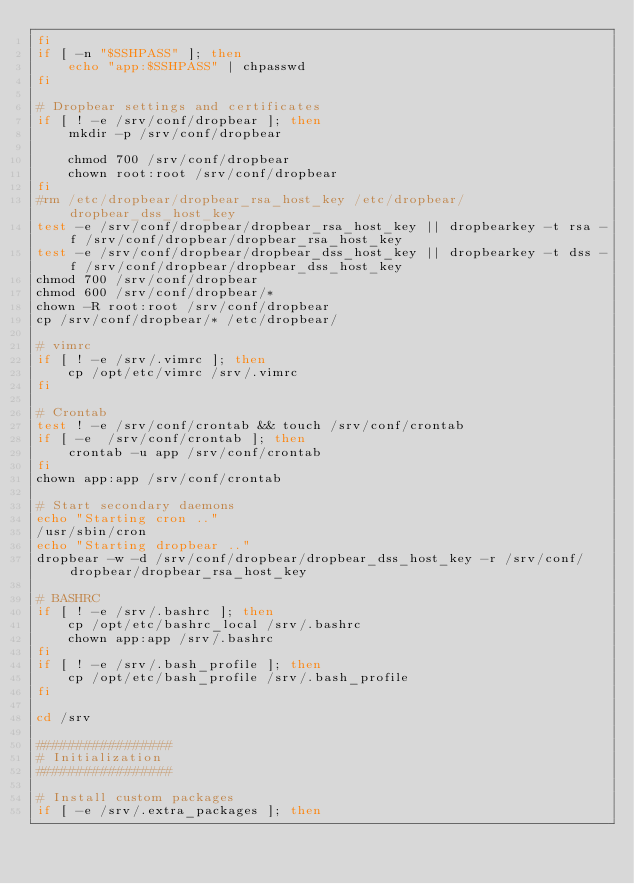Convert code to text. <code><loc_0><loc_0><loc_500><loc_500><_Bash_>fi
if [ -n "$SSHPASS" ]; then
    echo "app:$SSHPASS" | chpasswd
fi

# Dropbear settings and certificates
if [ ! -e /srv/conf/dropbear ]; then
    mkdir -p /srv/conf/dropbear

    chmod 700 /srv/conf/dropbear
    chown root:root /srv/conf/dropbear
fi
#rm /etc/dropbear/dropbear_rsa_host_key /etc/dropbear/dropbear_dss_host_key
test -e /srv/conf/dropbear/dropbear_rsa_host_key || dropbearkey -t rsa -f /srv/conf/dropbear/dropbear_rsa_host_key
test -e /srv/conf/dropbear/dropbear_dss_host_key || dropbearkey -t dss -f /srv/conf/dropbear/dropbear_dss_host_key
chmod 700 /srv/conf/dropbear
chmod 600 /srv/conf/dropbear/*
chown -R root:root /srv/conf/dropbear
cp /srv/conf/dropbear/* /etc/dropbear/

# vimrc
if [ ! -e /srv/.vimrc ]; then
    cp /opt/etc/vimrc /srv/.vimrc
fi

# Crontab
test ! -e /srv/conf/crontab && touch /srv/conf/crontab
if [ -e  /srv/conf/crontab ]; then
    crontab -u app /srv/conf/crontab
fi
chown app:app /srv/conf/crontab

# Start secondary daemons
echo "Starting cron .."
/usr/sbin/cron
echo "Starting dropbear .."
dropbear -w -d /srv/conf/dropbear/dropbear_dss_host_key -r /srv/conf/dropbear/dropbear_rsa_host_key

# BASHRC
if [ ! -e /srv/.bashrc ]; then
    cp /opt/etc/bashrc_local /srv/.bashrc
    chown app:app /srv/.bashrc
fi
if [ ! -e /srv/.bash_profile ]; then
    cp /opt/etc/bash_profile /srv/.bash_profile
fi

cd /srv

#################
# Initialization
#################

# Install custom packages
if [ -e /srv/.extra_packages ]; then</code> 